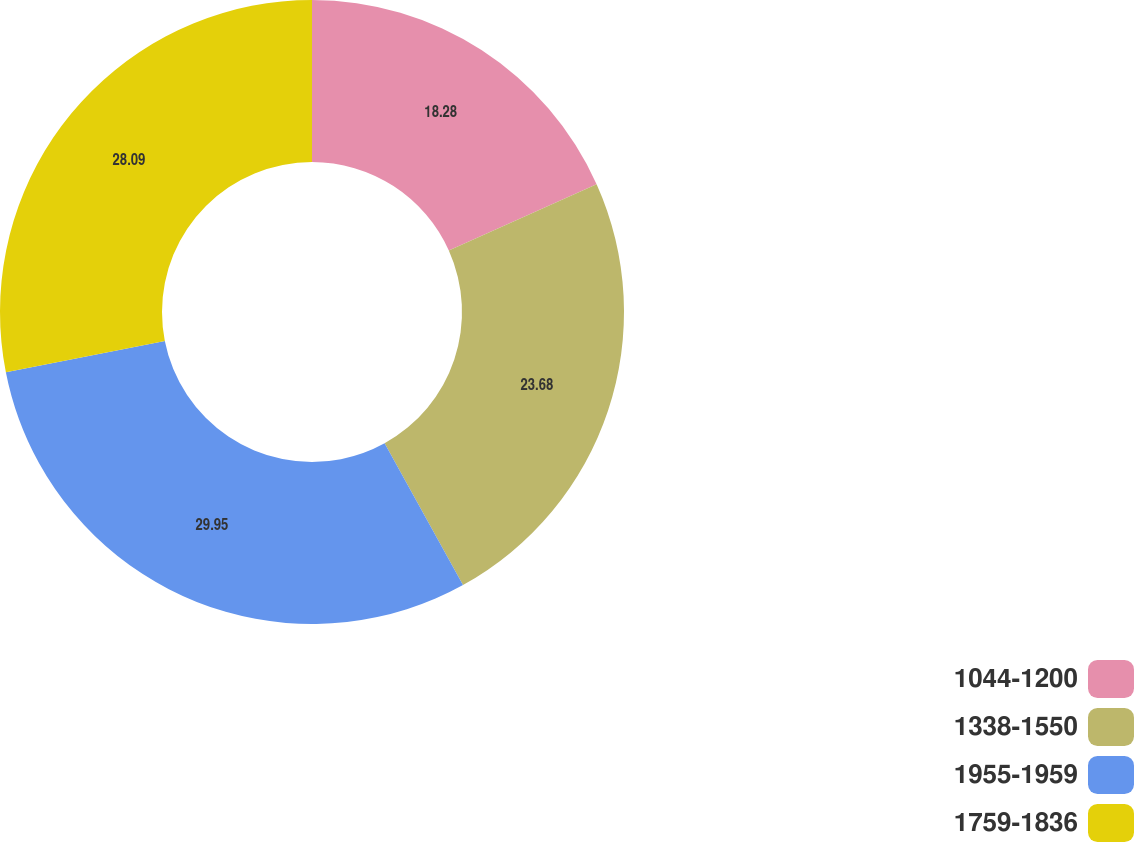<chart> <loc_0><loc_0><loc_500><loc_500><pie_chart><fcel>1044-1200<fcel>1338-1550<fcel>1955-1959<fcel>1759-1836<nl><fcel>18.28%<fcel>23.68%<fcel>29.95%<fcel>28.09%<nl></chart> 